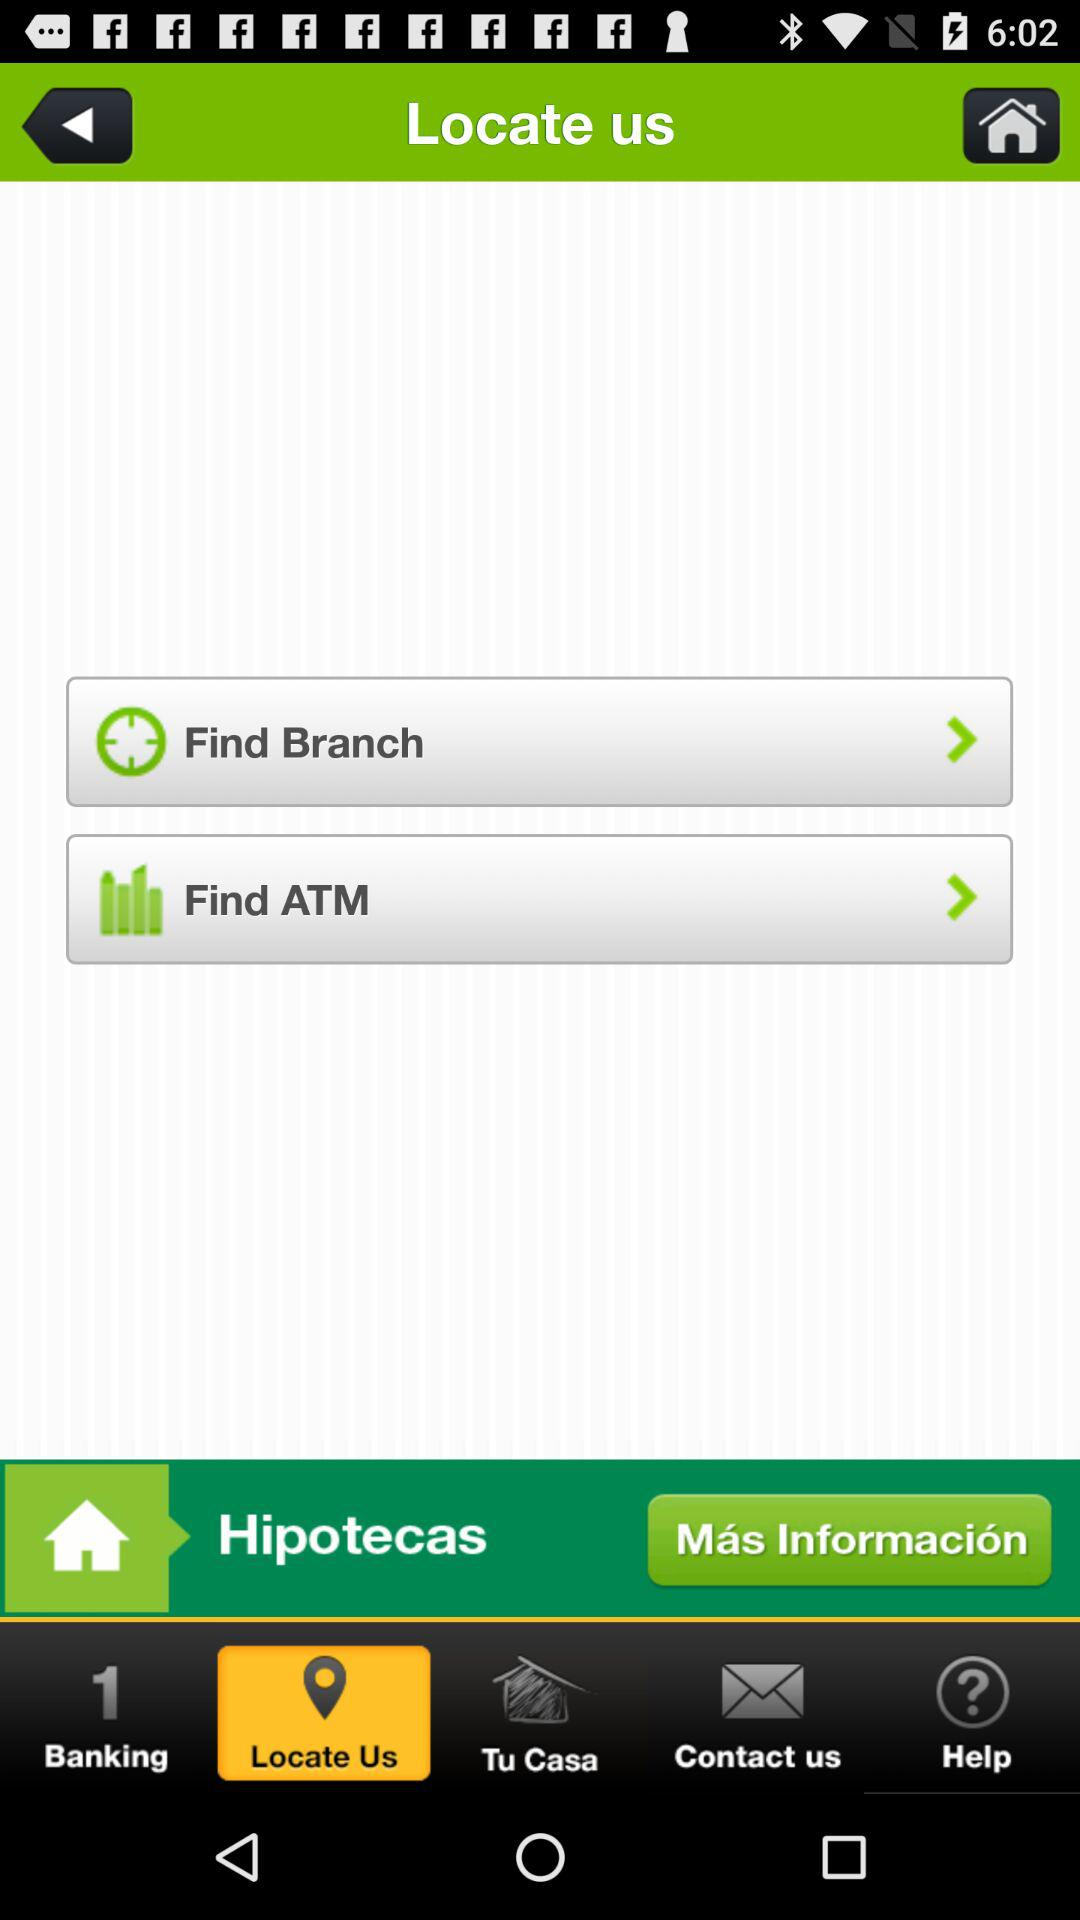Which tab has been selected? The tab "Locate Us" has been selected. 